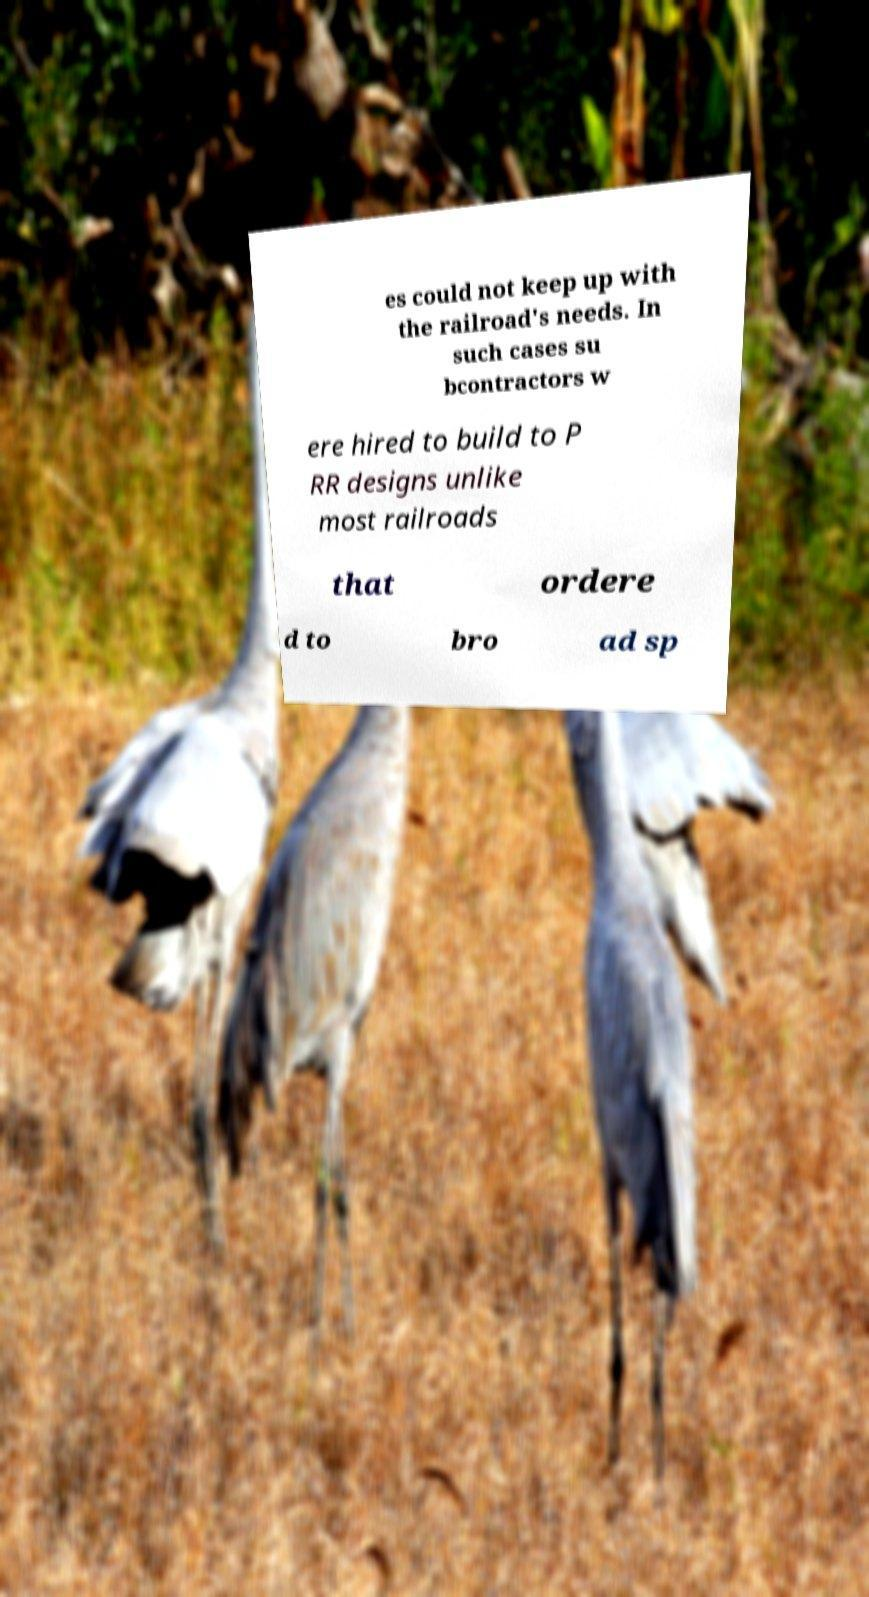Please identify and transcribe the text found in this image. es could not keep up with the railroad's needs. In such cases su bcontractors w ere hired to build to P RR designs unlike most railroads that ordere d to bro ad sp 